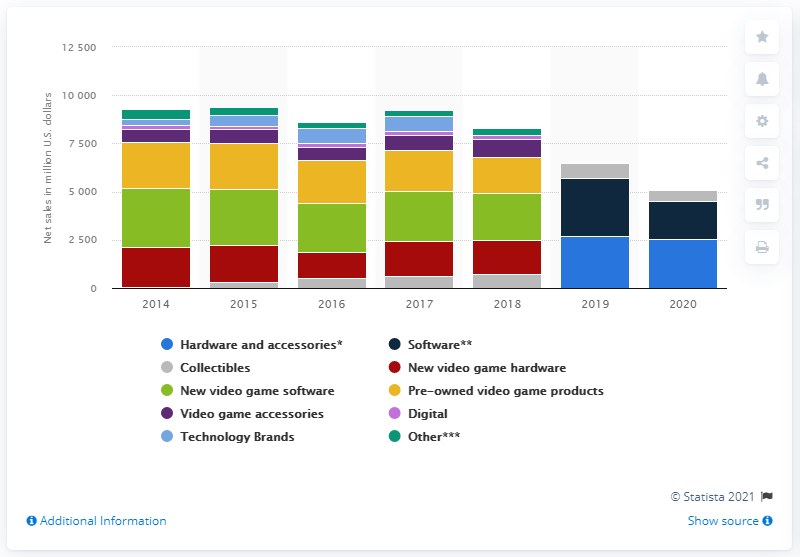Specify some key components in this picture. In the 2020 fiscal year, GameStop's net sales from its new video game software product category were $25,30.8 million. 